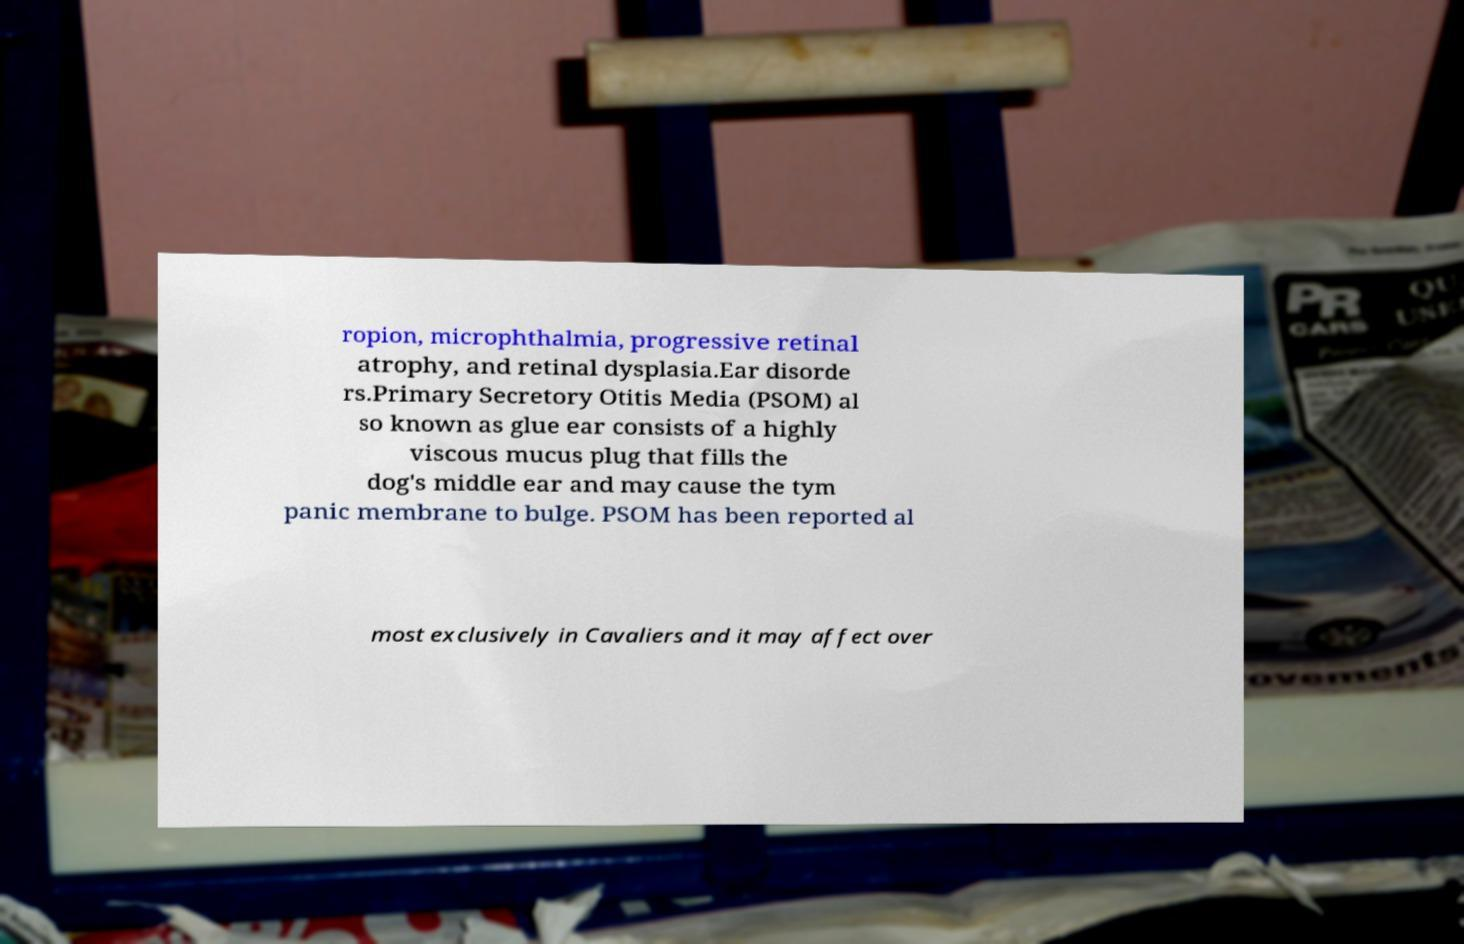For documentation purposes, I need the text within this image transcribed. Could you provide that? ropion, microphthalmia, progressive retinal atrophy, and retinal dysplasia.Ear disorde rs.Primary Secretory Otitis Media (PSOM) al so known as glue ear consists of a highly viscous mucus plug that fills the dog's middle ear and may cause the tym panic membrane to bulge. PSOM has been reported al most exclusively in Cavaliers and it may affect over 